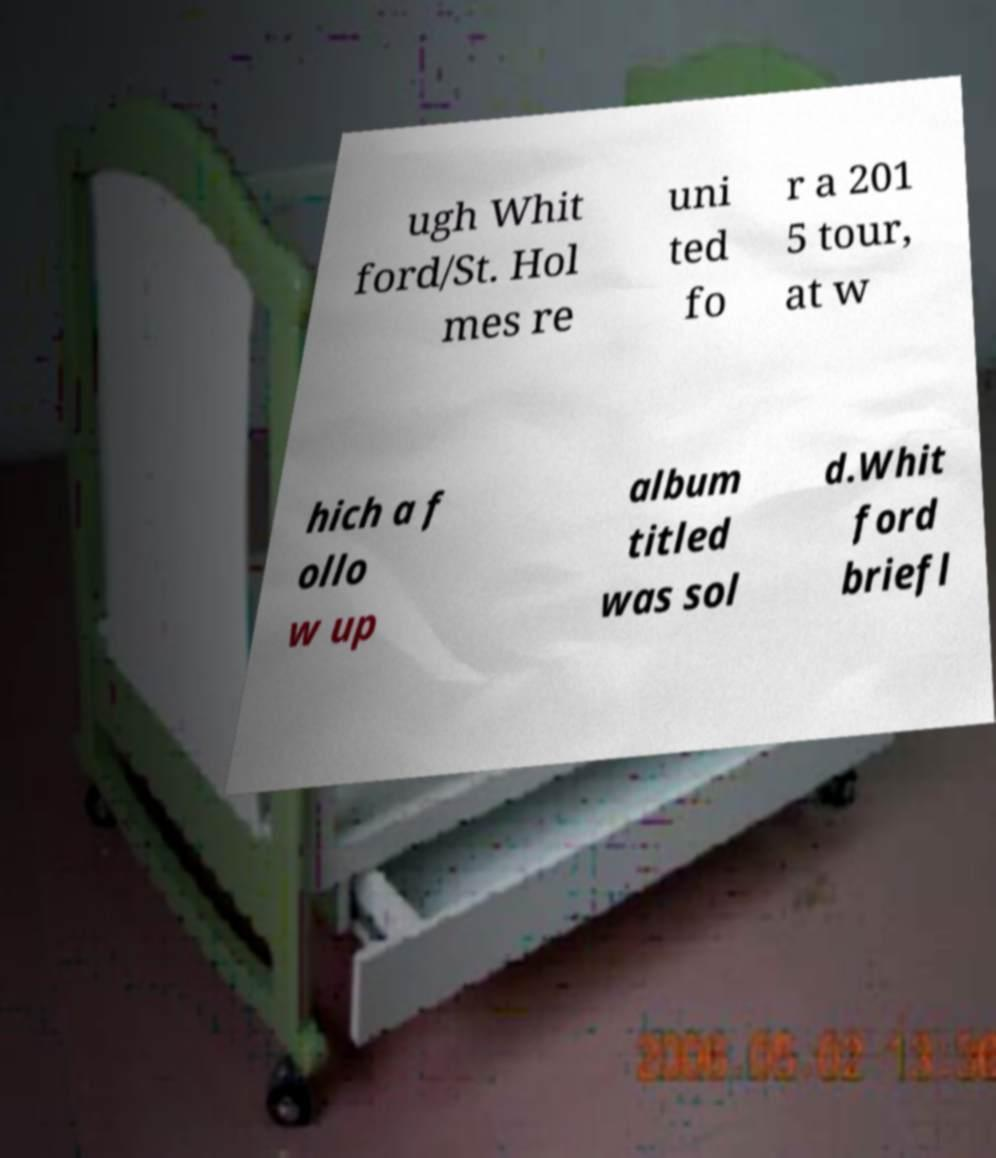Could you assist in decoding the text presented in this image and type it out clearly? ugh Whit ford/St. Hol mes re uni ted fo r a 201 5 tour, at w hich a f ollo w up album titled was sol d.Whit ford briefl 